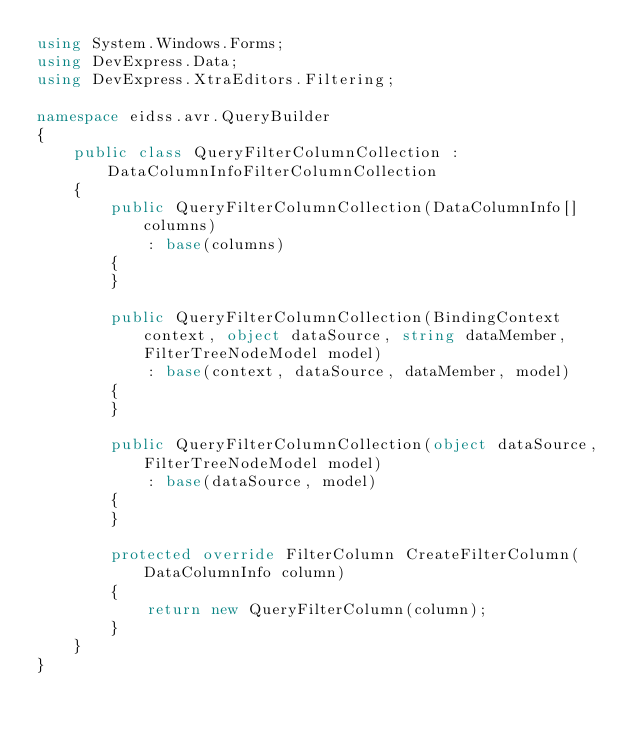Convert code to text. <code><loc_0><loc_0><loc_500><loc_500><_C#_>using System.Windows.Forms;
using DevExpress.Data;
using DevExpress.XtraEditors.Filtering;

namespace eidss.avr.QueryBuilder
{
    public class QueryFilterColumnCollection : DataColumnInfoFilterColumnCollection
    {
        public QueryFilterColumnCollection(DataColumnInfo[] columns)
            : base(columns)
        {
        }

        public QueryFilterColumnCollection(BindingContext context, object dataSource, string dataMember, FilterTreeNodeModel model)
            : base(context, dataSource, dataMember, model)
        {
        }

        public QueryFilterColumnCollection(object dataSource, FilterTreeNodeModel model)
            : base(dataSource, model)
        {
        }

        protected override FilterColumn CreateFilterColumn(DataColumnInfo column)
        {
            return new QueryFilterColumn(column);
        }
    }
}</code> 